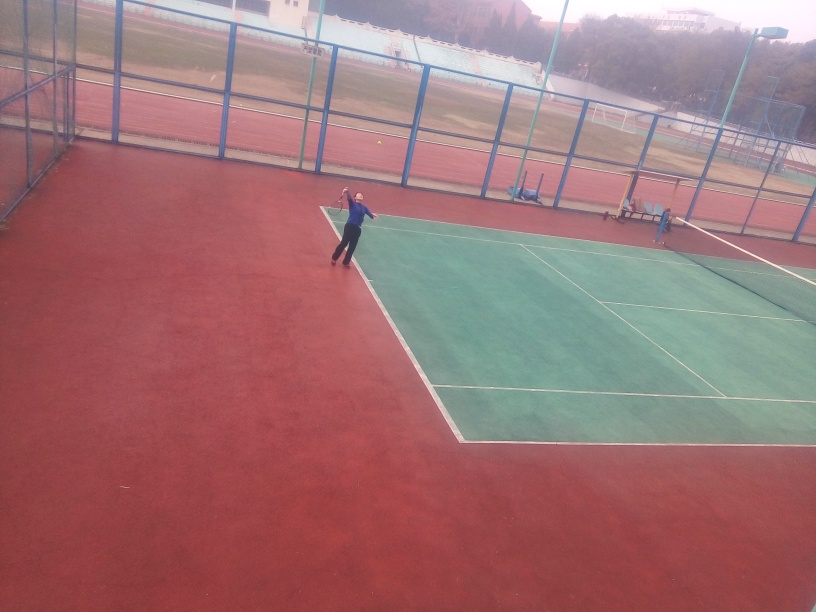Can you tell me more about how the scene is framed in the photo? The photo is taken from an angle where the tennis court is off-center, positioned more towards the left of the photo. The fence acts as a visual boundary, and the open space on the right side provides a sense of the environment beyond the court. Does the composition of this image affect the viewer's focus in any way? Indeed, the composition leads the viewer's eyes towards the player preparing to serve due to the positioning of the court. The negative space on the right may draw attention as well, potentially prompting curiosity about the wider setting surrounding the court. 